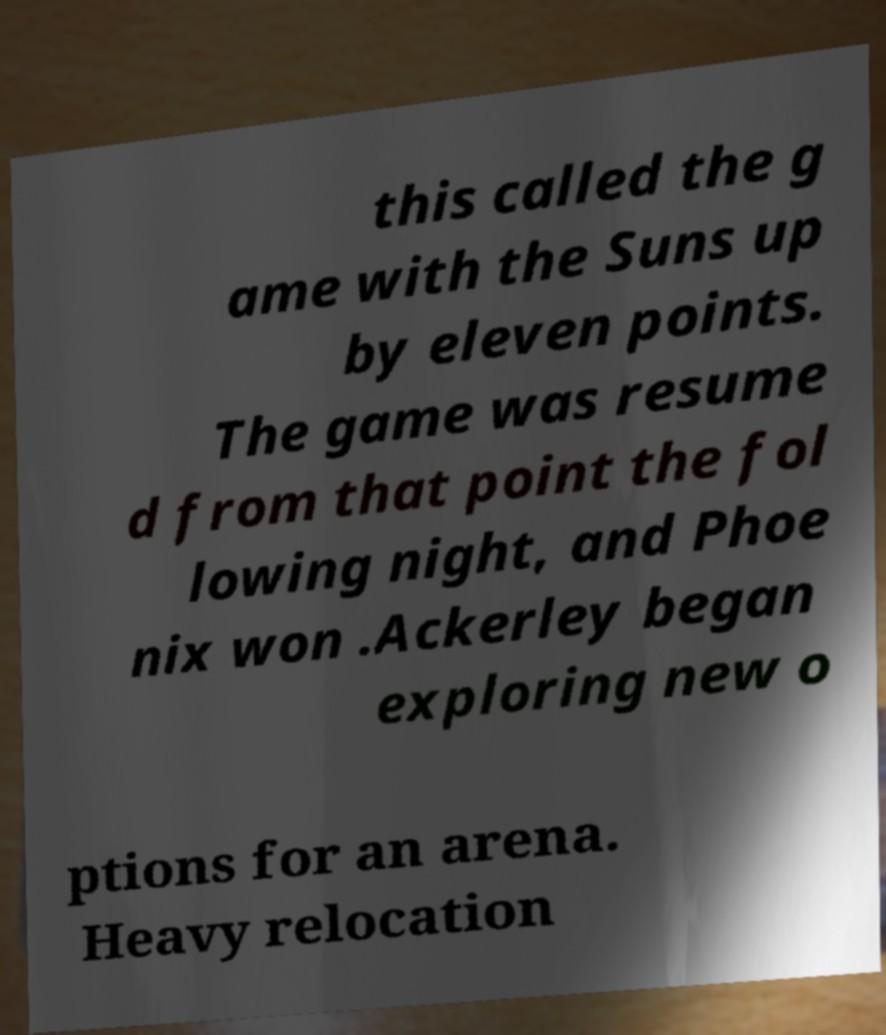What messages or text are displayed in this image? I need them in a readable, typed format. this called the g ame with the Suns up by eleven points. The game was resume d from that point the fol lowing night, and Phoe nix won .Ackerley began exploring new o ptions for an arena. Heavy relocation 